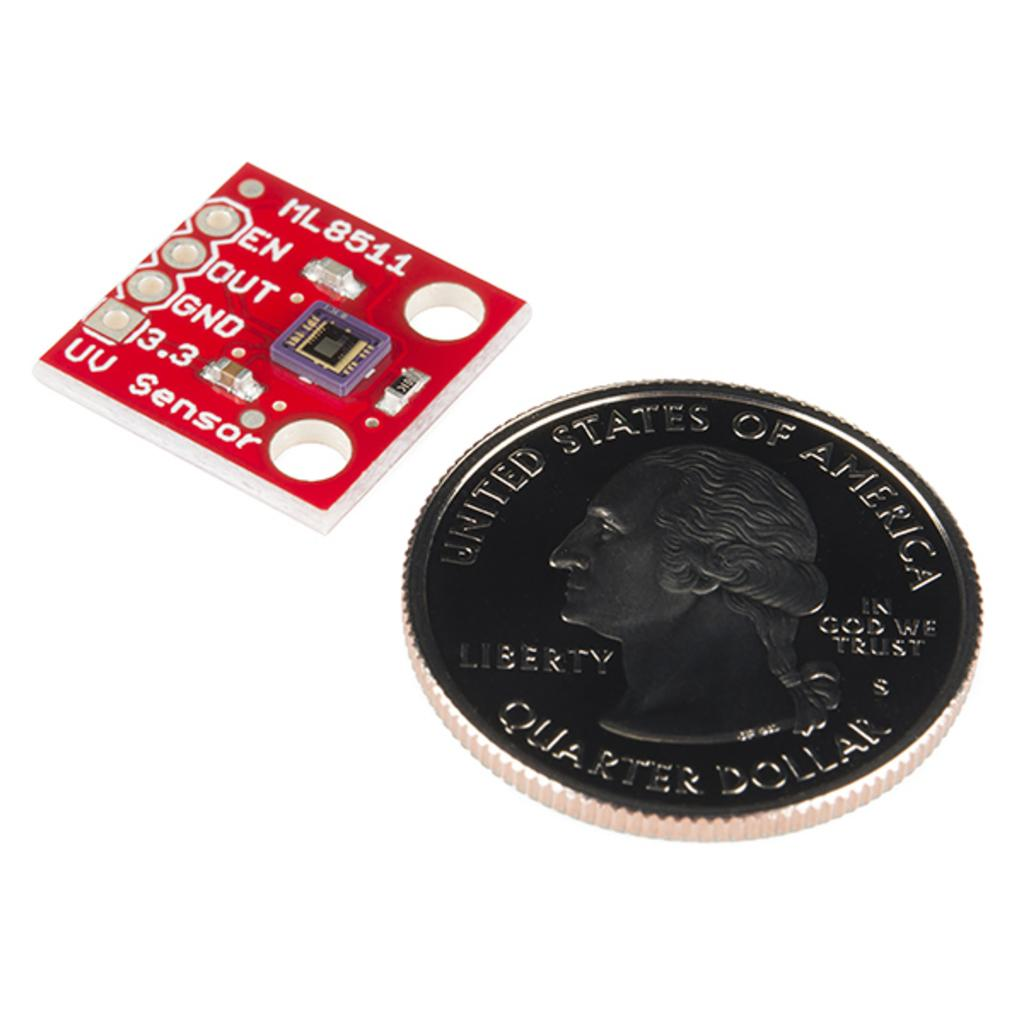<image>
Render a clear and concise summary of the photo. A US quarter dollar next to a micro chip 